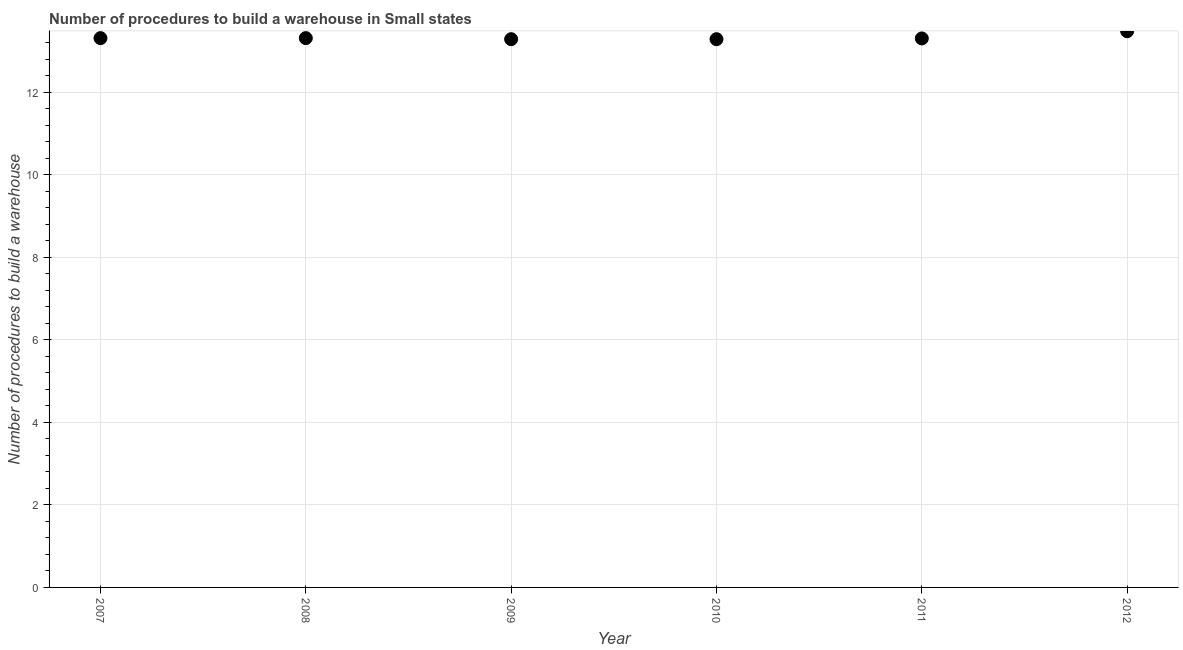What is the number of procedures to build a warehouse in 2010?
Ensure brevity in your answer.  13.28. Across all years, what is the maximum number of procedures to build a warehouse?
Provide a succinct answer. 13.47. Across all years, what is the minimum number of procedures to build a warehouse?
Keep it short and to the point. 13.28. In which year was the number of procedures to build a warehouse maximum?
Offer a very short reply. 2012. In which year was the number of procedures to build a warehouse minimum?
Provide a short and direct response. 2009. What is the sum of the number of procedures to build a warehouse?
Provide a short and direct response. 79.95. What is the difference between the number of procedures to build a warehouse in 2009 and 2011?
Ensure brevity in your answer.  -0.02. What is the average number of procedures to build a warehouse per year?
Make the answer very short. 13.33. What is the median number of procedures to build a warehouse?
Offer a very short reply. 13.3. In how many years, is the number of procedures to build a warehouse greater than 0.8 ?
Your response must be concise. 6. What is the ratio of the number of procedures to build a warehouse in 2008 to that in 2010?
Offer a very short reply. 1. What is the difference between the highest and the second highest number of procedures to build a warehouse?
Offer a terse response. 0.17. Is the sum of the number of procedures to build a warehouse in 2008 and 2012 greater than the maximum number of procedures to build a warehouse across all years?
Your response must be concise. Yes. What is the difference between the highest and the lowest number of procedures to build a warehouse?
Keep it short and to the point. 0.19. In how many years, is the number of procedures to build a warehouse greater than the average number of procedures to build a warehouse taken over all years?
Keep it short and to the point. 1. Does the number of procedures to build a warehouse monotonically increase over the years?
Give a very brief answer. No. How many dotlines are there?
Your response must be concise. 1. What is the difference between two consecutive major ticks on the Y-axis?
Keep it short and to the point. 2. Are the values on the major ticks of Y-axis written in scientific E-notation?
Offer a very short reply. No. What is the title of the graph?
Provide a short and direct response. Number of procedures to build a warehouse in Small states. What is the label or title of the X-axis?
Offer a very short reply. Year. What is the label or title of the Y-axis?
Give a very brief answer. Number of procedures to build a warehouse. What is the Number of procedures to build a warehouse in 2007?
Your response must be concise. 13.31. What is the Number of procedures to build a warehouse in 2008?
Your response must be concise. 13.31. What is the Number of procedures to build a warehouse in 2009?
Offer a very short reply. 13.28. What is the Number of procedures to build a warehouse in 2010?
Offer a terse response. 13.28. What is the Number of procedures to build a warehouse in 2011?
Your response must be concise. 13.3. What is the Number of procedures to build a warehouse in 2012?
Offer a very short reply. 13.47. What is the difference between the Number of procedures to build a warehouse in 2007 and 2009?
Make the answer very short. 0.03. What is the difference between the Number of procedures to build a warehouse in 2007 and 2010?
Make the answer very short. 0.03. What is the difference between the Number of procedures to build a warehouse in 2007 and 2011?
Offer a very short reply. 0.01. What is the difference between the Number of procedures to build a warehouse in 2007 and 2012?
Offer a very short reply. -0.17. What is the difference between the Number of procedures to build a warehouse in 2008 and 2009?
Provide a succinct answer. 0.03. What is the difference between the Number of procedures to build a warehouse in 2008 and 2010?
Ensure brevity in your answer.  0.03. What is the difference between the Number of procedures to build a warehouse in 2008 and 2011?
Offer a very short reply. 0.01. What is the difference between the Number of procedures to build a warehouse in 2008 and 2012?
Offer a very short reply. -0.17. What is the difference between the Number of procedures to build a warehouse in 2009 and 2010?
Your response must be concise. 0. What is the difference between the Number of procedures to build a warehouse in 2009 and 2011?
Offer a very short reply. -0.02. What is the difference between the Number of procedures to build a warehouse in 2009 and 2012?
Offer a terse response. -0.19. What is the difference between the Number of procedures to build a warehouse in 2010 and 2011?
Your response must be concise. -0.02. What is the difference between the Number of procedures to build a warehouse in 2010 and 2012?
Your response must be concise. -0.19. What is the difference between the Number of procedures to build a warehouse in 2011 and 2012?
Ensure brevity in your answer.  -0.17. What is the ratio of the Number of procedures to build a warehouse in 2007 to that in 2010?
Provide a succinct answer. 1. What is the ratio of the Number of procedures to build a warehouse in 2007 to that in 2011?
Offer a terse response. 1. What is the ratio of the Number of procedures to build a warehouse in 2008 to that in 2009?
Your answer should be compact. 1. What is the ratio of the Number of procedures to build a warehouse in 2008 to that in 2010?
Keep it short and to the point. 1. What is the ratio of the Number of procedures to build a warehouse in 2008 to that in 2012?
Ensure brevity in your answer.  0.99. What is the ratio of the Number of procedures to build a warehouse in 2009 to that in 2010?
Keep it short and to the point. 1. What is the ratio of the Number of procedures to build a warehouse in 2010 to that in 2011?
Offer a very short reply. 1. What is the ratio of the Number of procedures to build a warehouse in 2011 to that in 2012?
Ensure brevity in your answer.  0.99. 